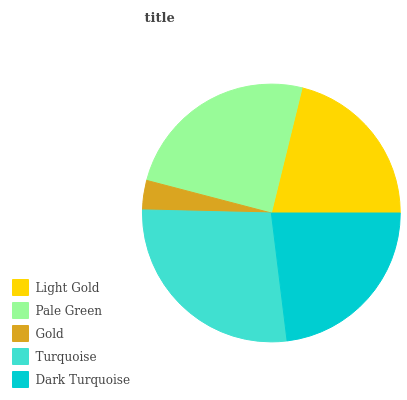Is Gold the minimum?
Answer yes or no. Yes. Is Turquoise the maximum?
Answer yes or no. Yes. Is Pale Green the minimum?
Answer yes or no. No. Is Pale Green the maximum?
Answer yes or no. No. Is Pale Green greater than Light Gold?
Answer yes or no. Yes. Is Light Gold less than Pale Green?
Answer yes or no. Yes. Is Light Gold greater than Pale Green?
Answer yes or no. No. Is Pale Green less than Light Gold?
Answer yes or no. No. Is Dark Turquoise the high median?
Answer yes or no. Yes. Is Dark Turquoise the low median?
Answer yes or no. Yes. Is Light Gold the high median?
Answer yes or no. No. Is Gold the low median?
Answer yes or no. No. 